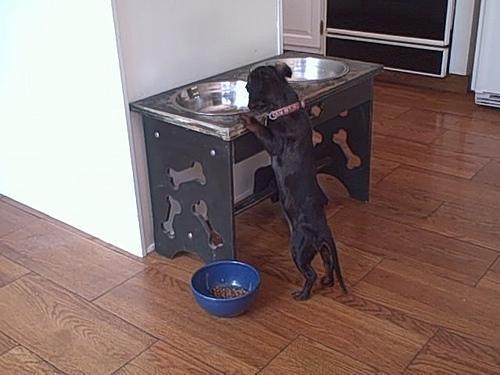How many dogs are in the picture?
Give a very brief answer. 1. 